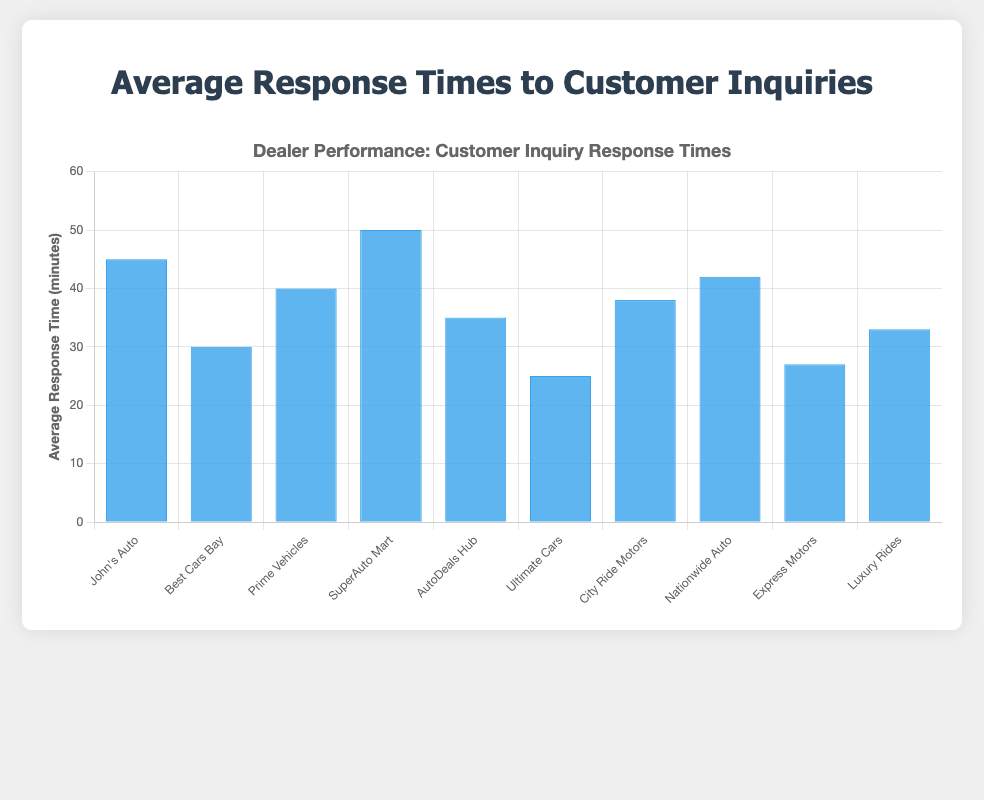Which dealer has the longest average response time? By looking at the heights of the blue bars, the dealer with the longest average response time is the one with the tallest bar. From the chart, SuperAuto Mart has the tallest bar, corresponding to 50 minutes.
Answer: SuperAuto Mart Which dealer has the shortest average response time? By observing the heights of the blue bars, the dealer with the shortest average response time is indicated by the shortest bar. From the chart, Ultimate Cars has the shortest bar, corresponding to 25 minutes.
Answer: Ultimate Cars How much longer is SuperAuto Mart's response time compared to Ultimate Cars? To find the difference in response times, subtract Ultimate Cars' response time from SuperAuto Mart's response time: 50 minutes - 25 minutes.
Answer: 25 minutes What is the average response time across all dealers? Add all the average response times together and then divide by the number of dealers: (45 + 30 + 40 + 50 + 35 + 25 + 38 + 42 + 27 + 33) / 10. First, the sum is 365, then divide by 10 to get the average.
Answer: 36.5 minutes Is John's Auto's response time greater than the overall average response time? Compare John's Auto's response time of 45 minutes with the overall average response time of 36.5 minutes. Since 45 is greater than 36.5, the answer is yes.
Answer: Yes Which dealers have a response time less than 35 minutes? Identify the bars with heights corresponding to response times under 35 minutes: Best Cars Bay (30), Ultimate Cars (25), Express Motors (27), and Luxury Rides (33).
Answer: Best Cars Bay, Ultimate Cars, Express Motors, Luxury Rides Rank the dealers from fastest to slowest response time. Arrange the bars in ascending order based on their heights: Ultimate Cars (25), Express Motors (27), Best Cars Bay (30), Luxury Rides (33), AutoDeals Hub (35), City Ride Motors (38), Prime Vehicles (40), Nationwide Auto (42), John's Auto (45), SuperAuto Mart (50).
Answer: Ultimate Cars, Express Motors, Best Cars Bay, Luxury Rides, AutoDeals Hub, City Ride Motors, Prime Vehicles, Nationwide Auto, John's Auto, SuperAuto Mart What is the median response time among the dealers? First, list the response times in ascending order: 25, 27, 30, 33, 35, 38, 40, 42, 45, 50. Then, find the middle value since there are 10 values: (35 + 38) / 2.
Answer: 36.5 minutes How much shorter is Express Motors' response time compared to Prime Vehicles? Find the difference between Prime Vehicles and Express Motors' response times: 40 minutes - 27 minutes.
Answer: 13 minutes Is there a bigger gap between John's Auto and Best Cars Bay or between SuperAuto Mart and Nationwide Auto? Calculate the difference for both pairs: John's Auto - Best Cars Bay is 45 - 30 = 15 minutes, while SuperAuto Mart - Nationwide Auto is 50 - 42 = 8 minutes.
Answer: John's Auto and Best Cars Bay 